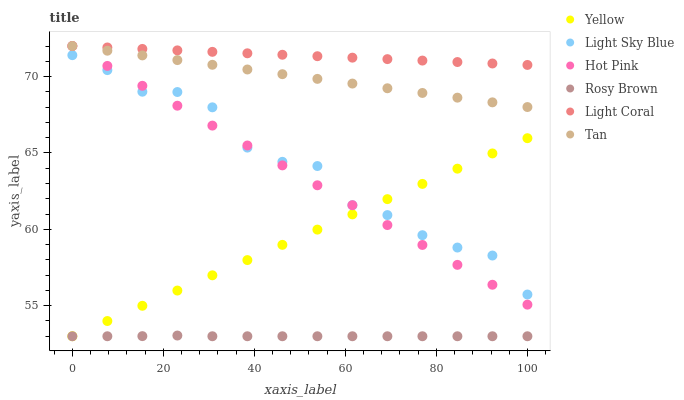Does Rosy Brown have the minimum area under the curve?
Answer yes or no. Yes. Does Light Coral have the maximum area under the curve?
Answer yes or no. Yes. Does Yellow have the minimum area under the curve?
Answer yes or no. No. Does Yellow have the maximum area under the curve?
Answer yes or no. No. Is Tan the smoothest?
Answer yes or no. Yes. Is Light Sky Blue the roughest?
Answer yes or no. Yes. Is Rosy Brown the smoothest?
Answer yes or no. No. Is Rosy Brown the roughest?
Answer yes or no. No. Does Rosy Brown have the lowest value?
Answer yes or no. Yes. Does Light Coral have the lowest value?
Answer yes or no. No. Does Tan have the highest value?
Answer yes or no. Yes. Does Yellow have the highest value?
Answer yes or no. No. Is Light Sky Blue less than Tan?
Answer yes or no. Yes. Is Light Sky Blue greater than Rosy Brown?
Answer yes or no. Yes. Does Light Sky Blue intersect Yellow?
Answer yes or no. Yes. Is Light Sky Blue less than Yellow?
Answer yes or no. No. Is Light Sky Blue greater than Yellow?
Answer yes or no. No. Does Light Sky Blue intersect Tan?
Answer yes or no. No. 